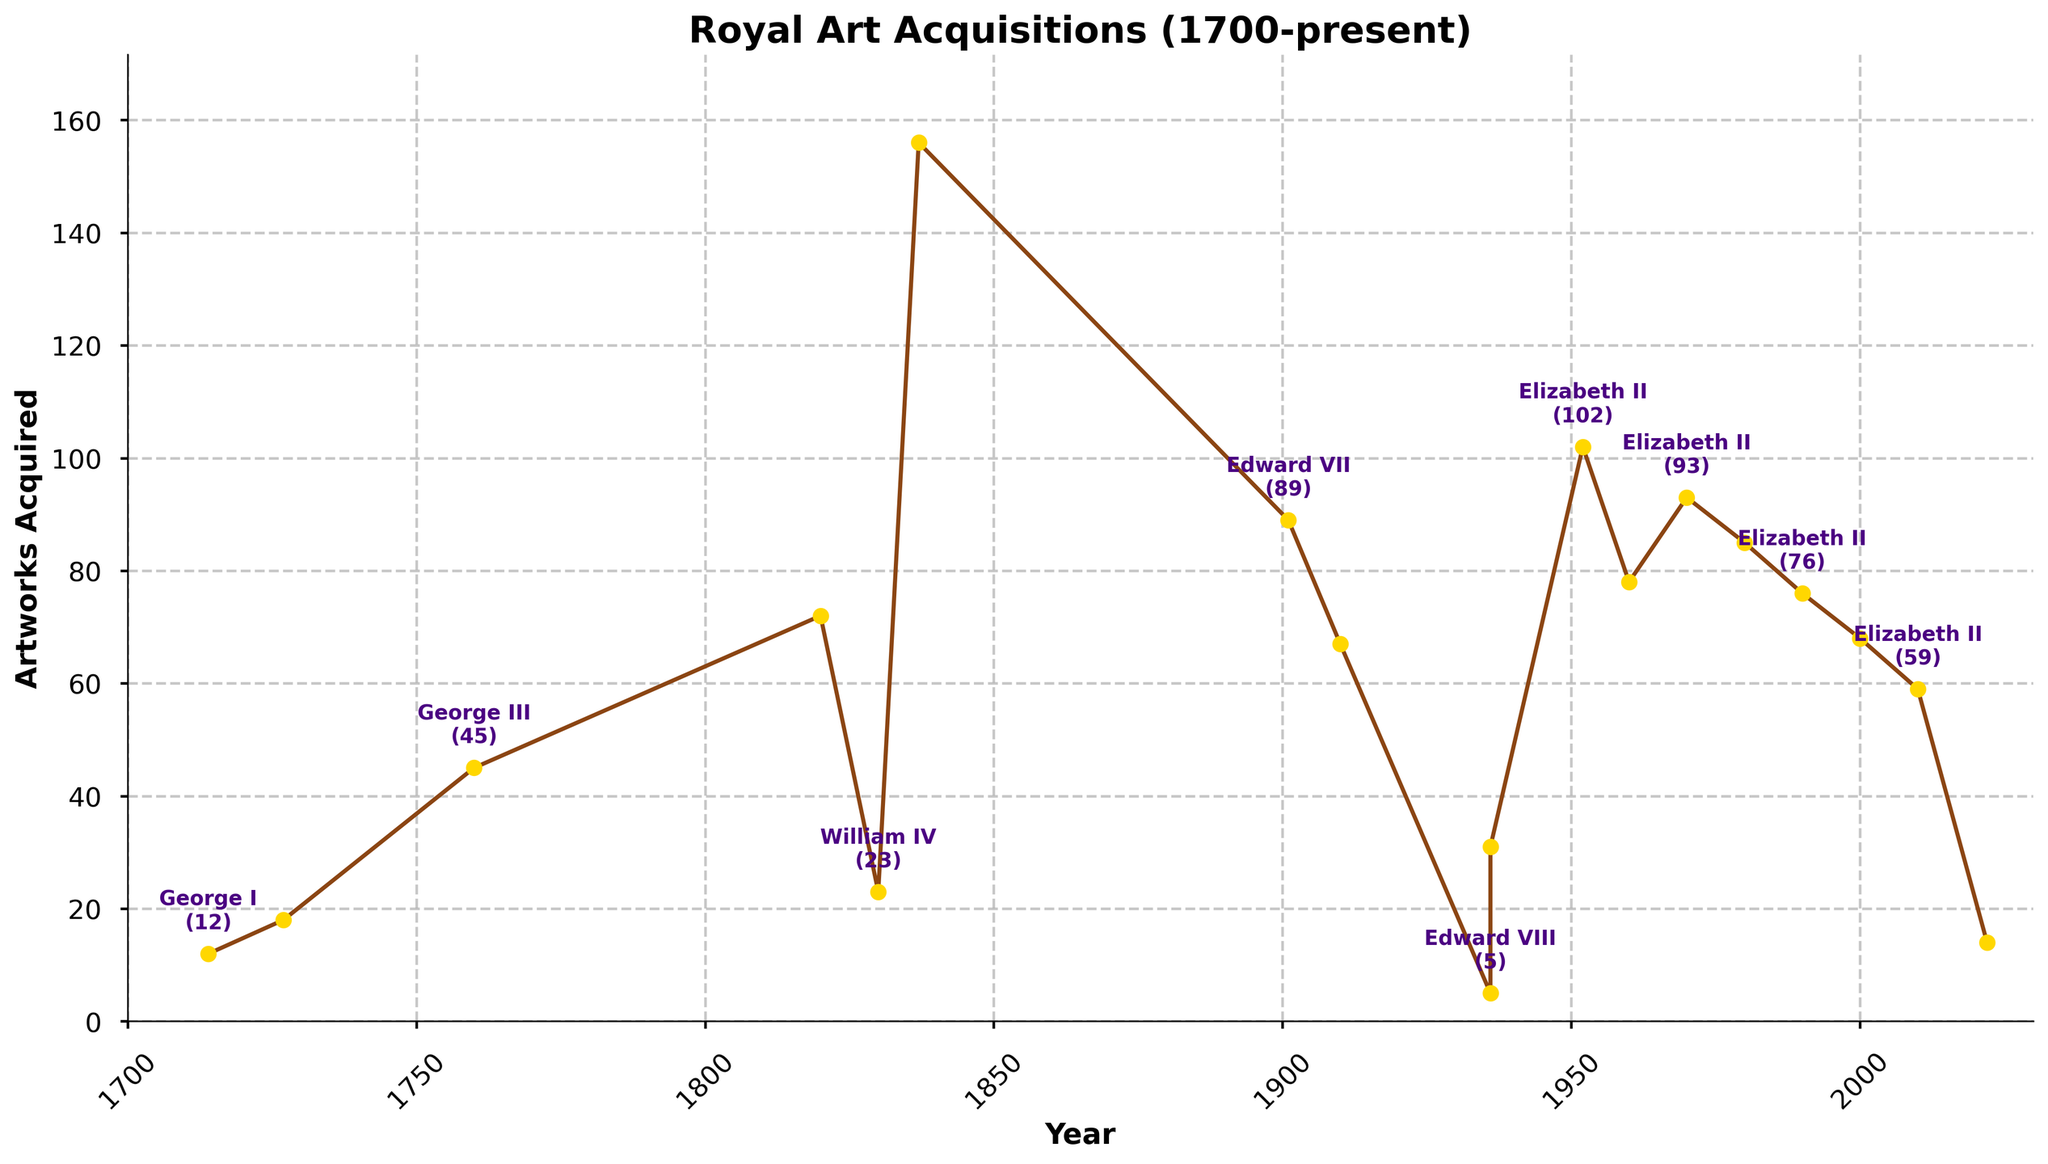What trend does the acquisition rate show from 1837 to 1901? The acquisition rate is highest in 1837 (Queen Victoria) and then declines significantly in 1901 (Edward VII). This suggests a peak in art acquisitions during Queen Victoria's reign, followed by a decrease.
Answer: Peak then decline During which monarch's reign do the British Royal Family acquire the most artworks? The figure shows that Queen Victoria's reign sees the highest number of art acquisitions, peaking at 156 in 1837.
Answer: Queen Victoria Compare the number of artworks acquired during George III's and Edward VII's reigns. Which is higher? George III acquired 45 artworks, while Edward VII acquired 89. Comparing these, Edward VII acquired more artworks than George III.
Answer: Edward VII How does the rate of art acquisitions during King George V's reign compare to that of King George VI's? King George V acquired 67 artworks whereas King George VI acquired 31. Therefore, King George V’s rate of acquisitions was higher.
Answer: George V's reign What is the general trend in the number of artworks acquired during Queen Elizabeth II's reign? The number of acquired artworks starts at 102 in 1952 and shows a general decreasing trend over the decades, dropping to 59 by 2010. Each decade generally sees fewer acquisitions than the previous one.
Answer: General decrease Which monarchs show a rapid decline in art acquisitions during their reign? Monarchs with noticeable rapid declines include Edward VIII (only 5 artworks) and Charles III with a low acquisition rate of 14 artworks compared to previous monarchs.
Answer: Edward VIII and Charles III What is the difference in the number of artworks acquired from George I to George IV? George I acquired 12 artworks and George IV acquired 72 artworks. The difference is 72 - 12 = 60 artworks.
Answer: 60 What is the average number of artworks acquired from 1952 to 2022 during Queen Elizabeth II's reign? Sum the number of artworks acquired in each year (102 + 78 + 93 + 85 + 76 + 68 + 59) and then divide by the number of data points (7). The total is 561 artworks over 7 periods, so the average is 561 / 7 = 80.14 artworks.
Answer: 80.14 artworks Which periods show an increase in acquisitions despite a general downward trend? Despite the general downward trend, the period from 1960 (78) to 1970 (93) in Queen Elizabeth II's reign shows an increase in the number of acquisitions.
Answer: 1960 to 1970 